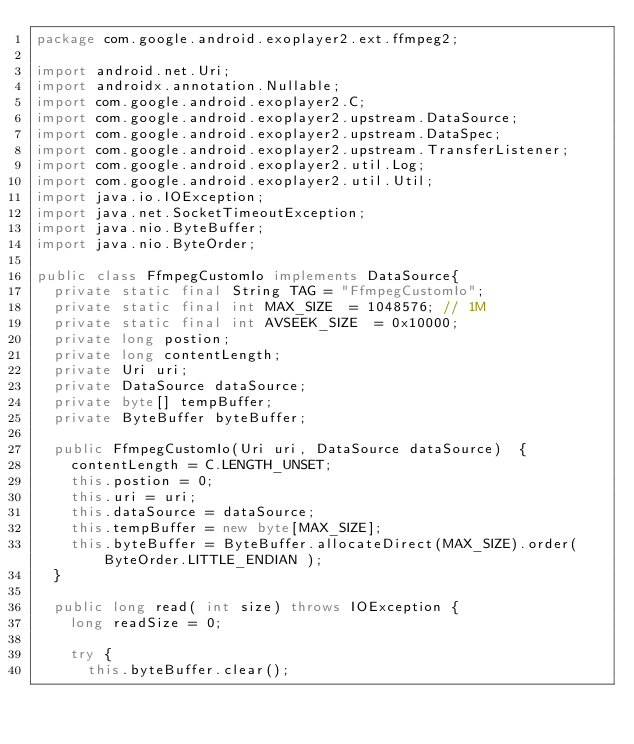Convert code to text. <code><loc_0><loc_0><loc_500><loc_500><_Java_>package com.google.android.exoplayer2.ext.ffmpeg2;

import android.net.Uri;
import androidx.annotation.Nullable;
import com.google.android.exoplayer2.C;
import com.google.android.exoplayer2.upstream.DataSource;
import com.google.android.exoplayer2.upstream.DataSpec;
import com.google.android.exoplayer2.upstream.TransferListener;
import com.google.android.exoplayer2.util.Log;
import com.google.android.exoplayer2.util.Util;
import java.io.IOException;
import java.net.SocketTimeoutException;
import java.nio.ByteBuffer;
import java.nio.ByteOrder;

public class FfmpegCustomIo implements DataSource{
  private static final String TAG = "FfmpegCustomIo";
  private static final int MAX_SIZE  = 1048576; // 1M
  private static final int AVSEEK_SIZE  = 0x10000;
  private long postion;
  private long contentLength;
  private Uri uri;
  private DataSource dataSource;
  private byte[] tempBuffer;
  private ByteBuffer byteBuffer;

  public FfmpegCustomIo(Uri uri, DataSource dataSource)  {
    contentLength = C.LENGTH_UNSET;
    this.postion = 0;
    this.uri = uri;
    this.dataSource = dataSource;
    this.tempBuffer = new byte[MAX_SIZE];
    this.byteBuffer = ByteBuffer.allocateDirect(MAX_SIZE).order( ByteOrder.LITTLE_ENDIAN );
  }

  public long read( int size) throws IOException {
    long readSize = 0;

    try {
      this.byteBuffer.clear();</code> 